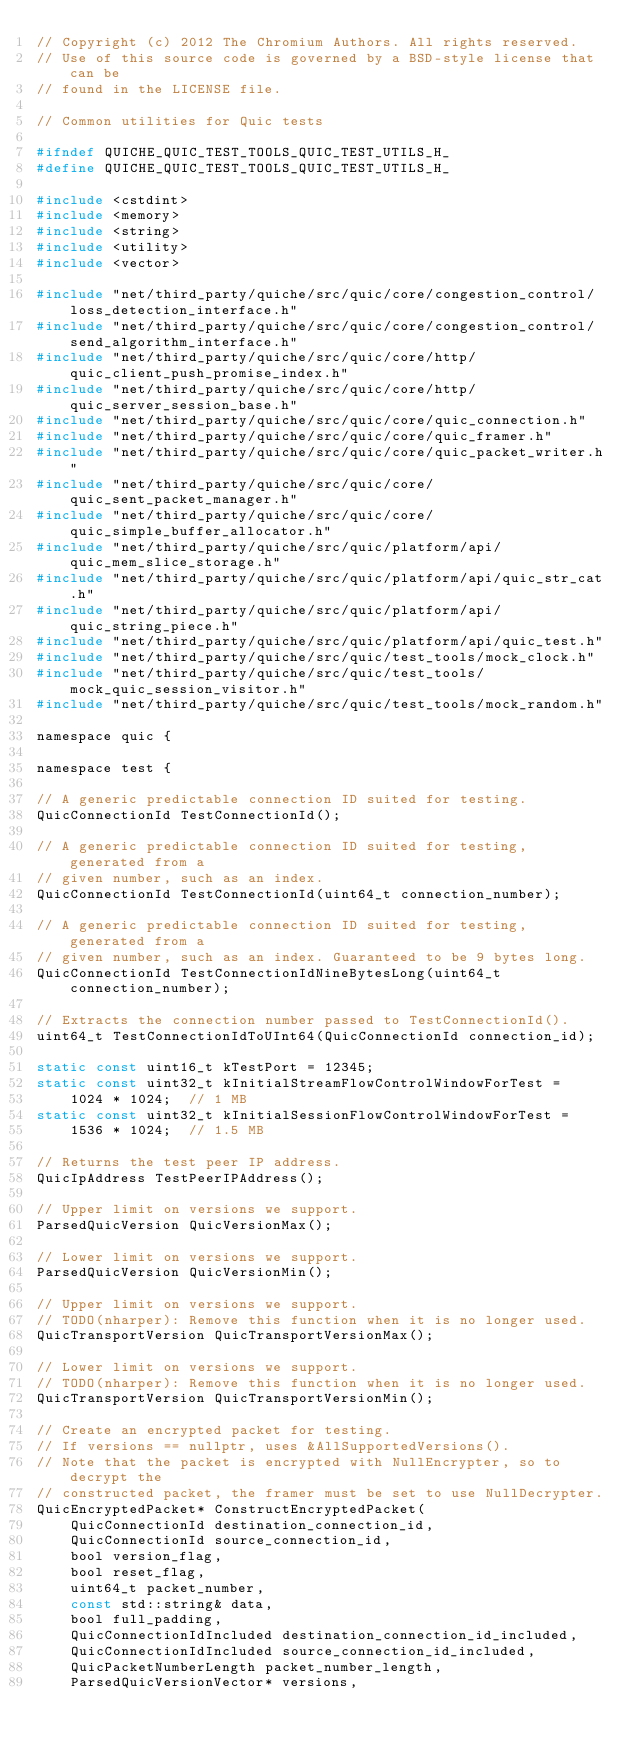Convert code to text. <code><loc_0><loc_0><loc_500><loc_500><_C_>// Copyright (c) 2012 The Chromium Authors. All rights reserved.
// Use of this source code is governed by a BSD-style license that can be
// found in the LICENSE file.

// Common utilities for Quic tests

#ifndef QUICHE_QUIC_TEST_TOOLS_QUIC_TEST_UTILS_H_
#define QUICHE_QUIC_TEST_TOOLS_QUIC_TEST_UTILS_H_

#include <cstdint>
#include <memory>
#include <string>
#include <utility>
#include <vector>

#include "net/third_party/quiche/src/quic/core/congestion_control/loss_detection_interface.h"
#include "net/third_party/quiche/src/quic/core/congestion_control/send_algorithm_interface.h"
#include "net/third_party/quiche/src/quic/core/http/quic_client_push_promise_index.h"
#include "net/third_party/quiche/src/quic/core/http/quic_server_session_base.h"
#include "net/third_party/quiche/src/quic/core/quic_connection.h"
#include "net/third_party/quiche/src/quic/core/quic_framer.h"
#include "net/third_party/quiche/src/quic/core/quic_packet_writer.h"
#include "net/third_party/quiche/src/quic/core/quic_sent_packet_manager.h"
#include "net/third_party/quiche/src/quic/core/quic_simple_buffer_allocator.h"
#include "net/third_party/quiche/src/quic/platform/api/quic_mem_slice_storage.h"
#include "net/third_party/quiche/src/quic/platform/api/quic_str_cat.h"
#include "net/third_party/quiche/src/quic/platform/api/quic_string_piece.h"
#include "net/third_party/quiche/src/quic/platform/api/quic_test.h"
#include "net/third_party/quiche/src/quic/test_tools/mock_clock.h"
#include "net/third_party/quiche/src/quic/test_tools/mock_quic_session_visitor.h"
#include "net/third_party/quiche/src/quic/test_tools/mock_random.h"

namespace quic {

namespace test {

// A generic predictable connection ID suited for testing.
QuicConnectionId TestConnectionId();

// A generic predictable connection ID suited for testing, generated from a
// given number, such as an index.
QuicConnectionId TestConnectionId(uint64_t connection_number);

// A generic predictable connection ID suited for testing, generated from a
// given number, such as an index. Guaranteed to be 9 bytes long.
QuicConnectionId TestConnectionIdNineBytesLong(uint64_t connection_number);

// Extracts the connection number passed to TestConnectionId().
uint64_t TestConnectionIdToUInt64(QuicConnectionId connection_id);

static const uint16_t kTestPort = 12345;
static const uint32_t kInitialStreamFlowControlWindowForTest =
    1024 * 1024;  // 1 MB
static const uint32_t kInitialSessionFlowControlWindowForTest =
    1536 * 1024;  // 1.5 MB

// Returns the test peer IP address.
QuicIpAddress TestPeerIPAddress();

// Upper limit on versions we support.
ParsedQuicVersion QuicVersionMax();

// Lower limit on versions we support.
ParsedQuicVersion QuicVersionMin();

// Upper limit on versions we support.
// TODO(nharper): Remove this function when it is no longer used.
QuicTransportVersion QuicTransportVersionMax();

// Lower limit on versions we support.
// TODO(nharper): Remove this function when it is no longer used.
QuicTransportVersion QuicTransportVersionMin();

// Create an encrypted packet for testing.
// If versions == nullptr, uses &AllSupportedVersions().
// Note that the packet is encrypted with NullEncrypter, so to decrypt the
// constructed packet, the framer must be set to use NullDecrypter.
QuicEncryptedPacket* ConstructEncryptedPacket(
    QuicConnectionId destination_connection_id,
    QuicConnectionId source_connection_id,
    bool version_flag,
    bool reset_flag,
    uint64_t packet_number,
    const std::string& data,
    bool full_padding,
    QuicConnectionIdIncluded destination_connection_id_included,
    QuicConnectionIdIncluded source_connection_id_included,
    QuicPacketNumberLength packet_number_length,
    ParsedQuicVersionVector* versions,</code> 